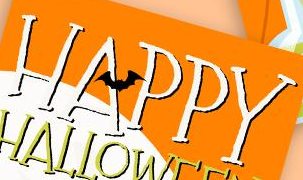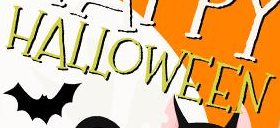Read the text from these images in sequence, separated by a semicolon. HAPPY; HALLOWEEN 